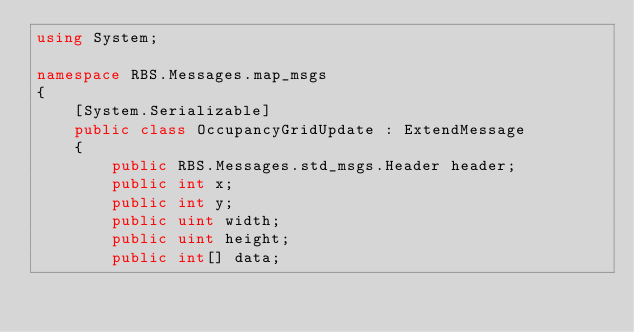<code> <loc_0><loc_0><loc_500><loc_500><_C#_>using System;

namespace RBS.Messages.map_msgs
{
    [System.Serializable]
    public class OccupancyGridUpdate : ExtendMessage
    {
        public RBS.Messages.std_msgs.Header header;
        public int x;
        public int y;
        public uint width;
        public uint height;
        public int[] data;</code> 